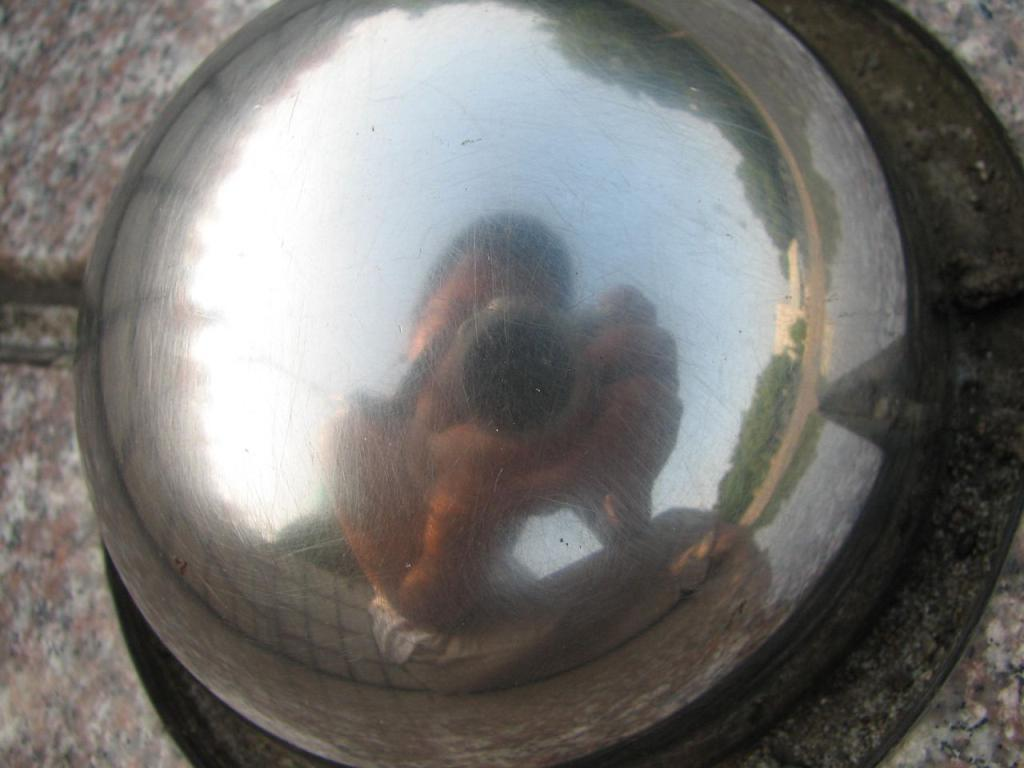What object can be seen in the image that is typically used for signaling or attracting attention? There is a bell in the image. What is the reflection of in the image? There is a reflection of a person holding a camera in the image. What type of vegetation is visible in the image? There are trees in the image. What type of structure can be seen in the image? There is a building in the image. What part of the natural environment is visible in the image? The sky is visible in the image. Where are the scissors located in the image? There are no scissors present in the image. How many passengers are visible in the image? There is no reference to passengers in the image; it features a bell, a reflection of a person holding a camera, trees, a building, and the sky. 